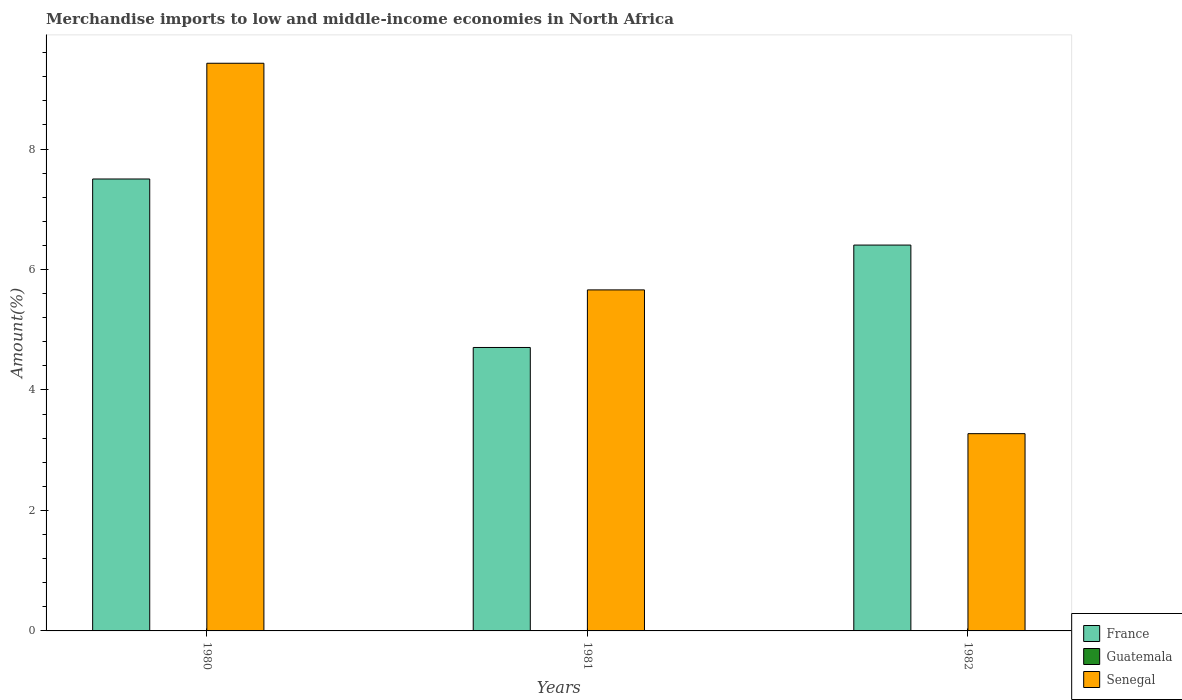Are the number of bars per tick equal to the number of legend labels?
Keep it short and to the point. Yes. Are the number of bars on each tick of the X-axis equal?
Your answer should be very brief. Yes. How many bars are there on the 3rd tick from the left?
Offer a terse response. 3. How many bars are there on the 1st tick from the right?
Your response must be concise. 3. What is the percentage of amount earned from merchandise imports in France in 1982?
Give a very brief answer. 6.41. Across all years, what is the maximum percentage of amount earned from merchandise imports in Senegal?
Ensure brevity in your answer.  9.42. Across all years, what is the minimum percentage of amount earned from merchandise imports in Guatemala?
Offer a very short reply. 0. In which year was the percentage of amount earned from merchandise imports in Senegal maximum?
Your answer should be compact. 1980. In which year was the percentage of amount earned from merchandise imports in Senegal minimum?
Your answer should be compact. 1982. What is the total percentage of amount earned from merchandise imports in France in the graph?
Ensure brevity in your answer.  18.61. What is the difference between the percentage of amount earned from merchandise imports in France in 1981 and that in 1982?
Offer a very short reply. -1.7. What is the difference between the percentage of amount earned from merchandise imports in Guatemala in 1982 and the percentage of amount earned from merchandise imports in France in 1980?
Keep it short and to the point. -7.5. What is the average percentage of amount earned from merchandise imports in Senegal per year?
Offer a very short reply. 6.12. In the year 1980, what is the difference between the percentage of amount earned from merchandise imports in France and percentage of amount earned from merchandise imports in Guatemala?
Your answer should be very brief. 7.5. In how many years, is the percentage of amount earned from merchandise imports in Senegal greater than 8.8 %?
Offer a terse response. 1. What is the ratio of the percentage of amount earned from merchandise imports in France in 1980 to that in 1981?
Provide a succinct answer. 1.59. What is the difference between the highest and the second highest percentage of amount earned from merchandise imports in France?
Make the answer very short. 1.1. What is the difference between the highest and the lowest percentage of amount earned from merchandise imports in France?
Make the answer very short. 2.8. Is the sum of the percentage of amount earned from merchandise imports in Senegal in 1980 and 1982 greater than the maximum percentage of amount earned from merchandise imports in France across all years?
Your response must be concise. Yes. What does the 3rd bar from the left in 1981 represents?
Ensure brevity in your answer.  Senegal. What does the 1st bar from the right in 1980 represents?
Provide a succinct answer. Senegal. How many years are there in the graph?
Your answer should be compact. 3. Are the values on the major ticks of Y-axis written in scientific E-notation?
Your response must be concise. No. Does the graph contain grids?
Provide a short and direct response. No. Where does the legend appear in the graph?
Your answer should be very brief. Bottom right. How many legend labels are there?
Give a very brief answer. 3. What is the title of the graph?
Your answer should be very brief. Merchandise imports to low and middle-income economies in North Africa. Does "Yemen, Rep." appear as one of the legend labels in the graph?
Your answer should be compact. No. What is the label or title of the Y-axis?
Keep it short and to the point. Amount(%). What is the Amount(%) of France in 1980?
Keep it short and to the point. 7.5. What is the Amount(%) of Guatemala in 1980?
Your response must be concise. 0. What is the Amount(%) in Senegal in 1980?
Offer a terse response. 9.42. What is the Amount(%) in France in 1981?
Keep it short and to the point. 4.71. What is the Amount(%) of Guatemala in 1981?
Provide a succinct answer. 0. What is the Amount(%) in Senegal in 1981?
Make the answer very short. 5.66. What is the Amount(%) of France in 1982?
Your response must be concise. 6.41. What is the Amount(%) of Guatemala in 1982?
Offer a terse response. 0. What is the Amount(%) of Senegal in 1982?
Give a very brief answer. 3.27. Across all years, what is the maximum Amount(%) of France?
Offer a terse response. 7.5. Across all years, what is the maximum Amount(%) in Guatemala?
Offer a very short reply. 0. Across all years, what is the maximum Amount(%) in Senegal?
Make the answer very short. 9.42. Across all years, what is the minimum Amount(%) of France?
Your response must be concise. 4.71. Across all years, what is the minimum Amount(%) in Guatemala?
Provide a short and direct response. 0. Across all years, what is the minimum Amount(%) of Senegal?
Offer a very short reply. 3.27. What is the total Amount(%) of France in the graph?
Your answer should be very brief. 18.61. What is the total Amount(%) of Guatemala in the graph?
Provide a succinct answer. 0. What is the total Amount(%) of Senegal in the graph?
Provide a short and direct response. 18.36. What is the difference between the Amount(%) of France in 1980 and that in 1981?
Offer a terse response. 2.8. What is the difference between the Amount(%) in Guatemala in 1980 and that in 1981?
Keep it short and to the point. -0. What is the difference between the Amount(%) in Senegal in 1980 and that in 1981?
Your answer should be compact. 3.76. What is the difference between the Amount(%) of France in 1980 and that in 1982?
Offer a very short reply. 1.1. What is the difference between the Amount(%) in Guatemala in 1980 and that in 1982?
Provide a short and direct response. -0. What is the difference between the Amount(%) in Senegal in 1980 and that in 1982?
Offer a terse response. 6.15. What is the difference between the Amount(%) in France in 1981 and that in 1982?
Provide a succinct answer. -1.7. What is the difference between the Amount(%) of Guatemala in 1981 and that in 1982?
Give a very brief answer. 0. What is the difference between the Amount(%) of Senegal in 1981 and that in 1982?
Make the answer very short. 2.39. What is the difference between the Amount(%) of France in 1980 and the Amount(%) of Guatemala in 1981?
Ensure brevity in your answer.  7.5. What is the difference between the Amount(%) in France in 1980 and the Amount(%) in Senegal in 1981?
Provide a succinct answer. 1.84. What is the difference between the Amount(%) of Guatemala in 1980 and the Amount(%) of Senegal in 1981?
Provide a short and direct response. -5.66. What is the difference between the Amount(%) in France in 1980 and the Amount(%) in Guatemala in 1982?
Ensure brevity in your answer.  7.5. What is the difference between the Amount(%) of France in 1980 and the Amount(%) of Senegal in 1982?
Offer a very short reply. 4.23. What is the difference between the Amount(%) of Guatemala in 1980 and the Amount(%) of Senegal in 1982?
Your response must be concise. -3.27. What is the difference between the Amount(%) of France in 1981 and the Amount(%) of Guatemala in 1982?
Provide a succinct answer. 4.7. What is the difference between the Amount(%) in France in 1981 and the Amount(%) in Senegal in 1982?
Give a very brief answer. 1.43. What is the difference between the Amount(%) of Guatemala in 1981 and the Amount(%) of Senegal in 1982?
Keep it short and to the point. -3.27. What is the average Amount(%) in France per year?
Your response must be concise. 6.2. What is the average Amount(%) of Guatemala per year?
Provide a succinct answer. 0. What is the average Amount(%) in Senegal per year?
Offer a terse response. 6.12. In the year 1980, what is the difference between the Amount(%) in France and Amount(%) in Guatemala?
Provide a succinct answer. 7.5. In the year 1980, what is the difference between the Amount(%) in France and Amount(%) in Senegal?
Provide a short and direct response. -1.92. In the year 1980, what is the difference between the Amount(%) of Guatemala and Amount(%) of Senegal?
Provide a succinct answer. -9.42. In the year 1981, what is the difference between the Amount(%) in France and Amount(%) in Guatemala?
Make the answer very short. 4.7. In the year 1981, what is the difference between the Amount(%) of France and Amount(%) of Senegal?
Make the answer very short. -0.96. In the year 1981, what is the difference between the Amount(%) of Guatemala and Amount(%) of Senegal?
Keep it short and to the point. -5.66. In the year 1982, what is the difference between the Amount(%) of France and Amount(%) of Guatemala?
Ensure brevity in your answer.  6.4. In the year 1982, what is the difference between the Amount(%) in France and Amount(%) in Senegal?
Ensure brevity in your answer.  3.13. In the year 1982, what is the difference between the Amount(%) in Guatemala and Amount(%) in Senegal?
Keep it short and to the point. -3.27. What is the ratio of the Amount(%) in France in 1980 to that in 1981?
Your answer should be compact. 1.59. What is the ratio of the Amount(%) in Guatemala in 1980 to that in 1981?
Offer a terse response. 0.25. What is the ratio of the Amount(%) in Senegal in 1980 to that in 1981?
Make the answer very short. 1.66. What is the ratio of the Amount(%) of France in 1980 to that in 1982?
Provide a short and direct response. 1.17. What is the ratio of the Amount(%) in Guatemala in 1980 to that in 1982?
Provide a short and direct response. 0.51. What is the ratio of the Amount(%) in Senegal in 1980 to that in 1982?
Your answer should be compact. 2.88. What is the ratio of the Amount(%) of France in 1981 to that in 1982?
Give a very brief answer. 0.73. What is the ratio of the Amount(%) in Guatemala in 1981 to that in 1982?
Your answer should be compact. 2. What is the ratio of the Amount(%) in Senegal in 1981 to that in 1982?
Offer a terse response. 1.73. What is the difference between the highest and the second highest Amount(%) of France?
Keep it short and to the point. 1.1. What is the difference between the highest and the second highest Amount(%) of Guatemala?
Give a very brief answer. 0. What is the difference between the highest and the second highest Amount(%) of Senegal?
Make the answer very short. 3.76. What is the difference between the highest and the lowest Amount(%) of France?
Your answer should be very brief. 2.8. What is the difference between the highest and the lowest Amount(%) of Guatemala?
Your response must be concise. 0. What is the difference between the highest and the lowest Amount(%) in Senegal?
Give a very brief answer. 6.15. 